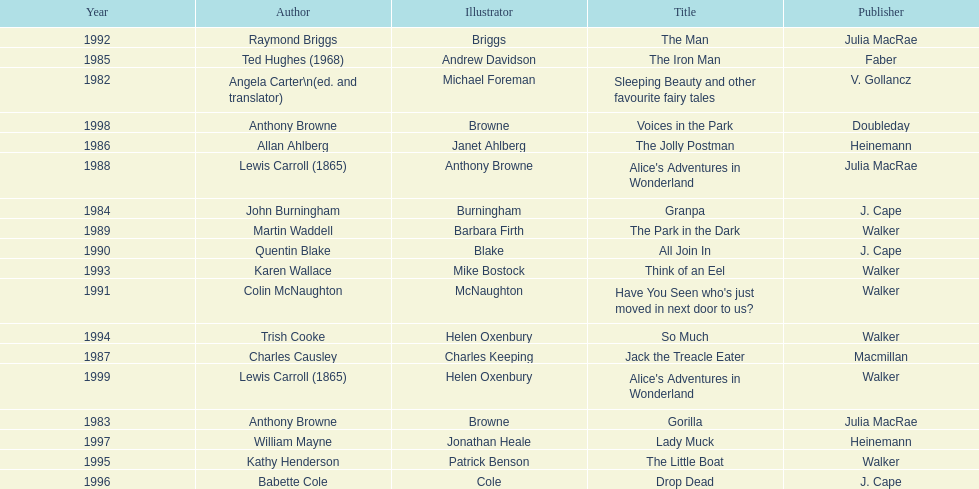Write the full table. {'header': ['Year', 'Author', 'Illustrator', 'Title', 'Publisher'], 'rows': [['1992', 'Raymond Briggs', 'Briggs', 'The Man', 'Julia MacRae'], ['1985', 'Ted Hughes (1968)', 'Andrew Davidson', 'The Iron Man', 'Faber'], ['1982', 'Angela Carter\\n(ed. and translator)', 'Michael Foreman', 'Sleeping Beauty and other favourite fairy tales', 'V. Gollancz'], ['1998', 'Anthony Browne', 'Browne', 'Voices in the Park', 'Doubleday'], ['1986', 'Allan Ahlberg', 'Janet Ahlberg', 'The Jolly Postman', 'Heinemann'], ['1988', 'Lewis Carroll (1865)', 'Anthony Browne', "Alice's Adventures in Wonderland", 'Julia MacRae'], ['1984', 'John Burningham', 'Burningham', 'Granpa', 'J. Cape'], ['1989', 'Martin Waddell', 'Barbara Firth', 'The Park in the Dark', 'Walker'], ['1990', 'Quentin Blake', 'Blake', 'All Join In', 'J. Cape'], ['1993', 'Karen Wallace', 'Mike Bostock', 'Think of an Eel', 'Walker'], ['1991', 'Colin McNaughton', 'McNaughton', "Have You Seen who's just moved in next door to us?", 'Walker'], ['1994', 'Trish Cooke', 'Helen Oxenbury', 'So Much', 'Walker'], ['1987', 'Charles Causley', 'Charles Keeping', 'Jack the Treacle Eater', 'Macmillan'], ['1999', 'Lewis Carroll (1865)', 'Helen Oxenbury', "Alice's Adventures in Wonderland", 'Walker'], ['1983', 'Anthony Browne', 'Browne', 'Gorilla', 'Julia MacRae'], ['1997', 'William Mayne', 'Jonathan Heale', 'Lady Muck', 'Heinemann'], ['1995', 'Kathy Henderson', 'Patrick Benson', 'The Little Boat', 'Walker'], ['1996', 'Babette Cole', 'Cole', 'Drop Dead', 'J. Cape']]} How many titles had the same author listed as the illustrator? 7. 